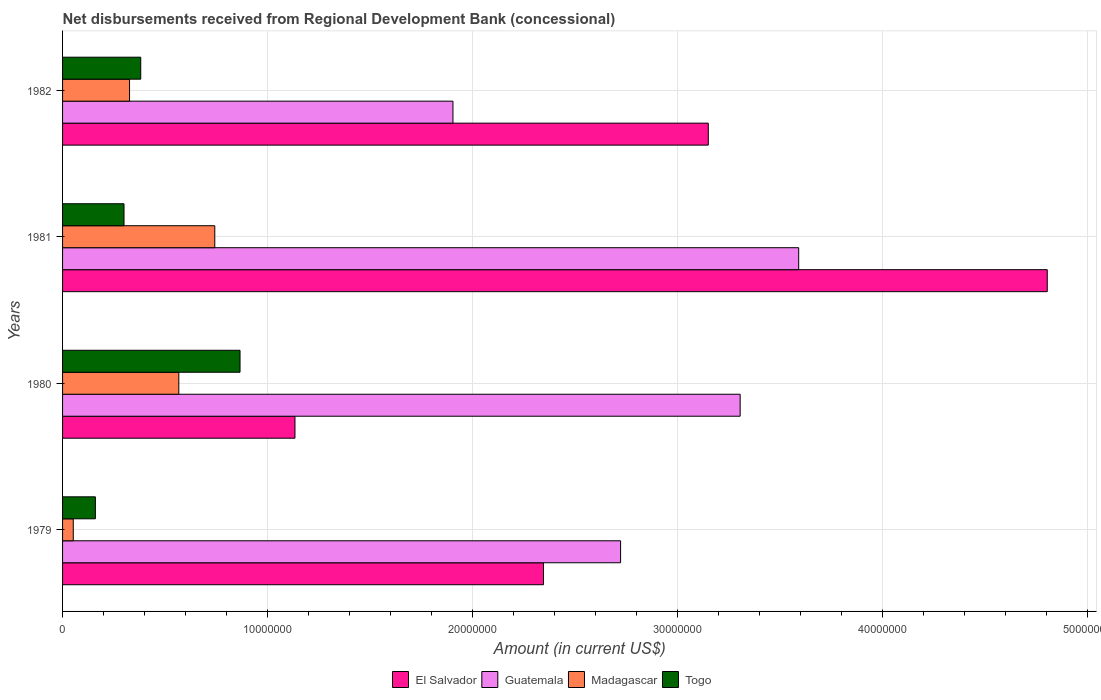How many groups of bars are there?
Make the answer very short. 4. Are the number of bars per tick equal to the number of legend labels?
Provide a short and direct response. Yes. In how many cases, is the number of bars for a given year not equal to the number of legend labels?
Your response must be concise. 0. What is the amount of disbursements received from Regional Development Bank in El Salvador in 1979?
Provide a succinct answer. 2.35e+07. Across all years, what is the maximum amount of disbursements received from Regional Development Bank in Madagascar?
Keep it short and to the point. 7.43e+06. Across all years, what is the minimum amount of disbursements received from Regional Development Bank in El Salvador?
Give a very brief answer. 1.13e+07. In which year was the amount of disbursements received from Regional Development Bank in Madagascar minimum?
Provide a short and direct response. 1979. What is the total amount of disbursements received from Regional Development Bank in Madagascar in the graph?
Offer a very short reply. 1.69e+07. What is the difference between the amount of disbursements received from Regional Development Bank in El Salvador in 1980 and that in 1981?
Offer a very short reply. -3.67e+07. What is the difference between the amount of disbursements received from Regional Development Bank in Guatemala in 1979 and the amount of disbursements received from Regional Development Bank in Madagascar in 1982?
Give a very brief answer. 2.40e+07. What is the average amount of disbursements received from Regional Development Bank in Madagascar per year?
Provide a succinct answer. 4.22e+06. In the year 1979, what is the difference between the amount of disbursements received from Regional Development Bank in Madagascar and amount of disbursements received from Regional Development Bank in Togo?
Ensure brevity in your answer.  -1.08e+06. In how many years, is the amount of disbursements received from Regional Development Bank in Madagascar greater than 34000000 US$?
Your answer should be compact. 0. What is the ratio of the amount of disbursements received from Regional Development Bank in El Salvador in 1979 to that in 1981?
Provide a succinct answer. 0.49. What is the difference between the highest and the second highest amount of disbursements received from Regional Development Bank in Togo?
Keep it short and to the point. 4.84e+06. What is the difference between the highest and the lowest amount of disbursements received from Regional Development Bank in Togo?
Keep it short and to the point. 7.06e+06. Is it the case that in every year, the sum of the amount of disbursements received from Regional Development Bank in Guatemala and amount of disbursements received from Regional Development Bank in Togo is greater than the sum of amount of disbursements received from Regional Development Bank in El Salvador and amount of disbursements received from Regional Development Bank in Madagascar?
Ensure brevity in your answer.  Yes. What does the 4th bar from the top in 1980 represents?
Give a very brief answer. El Salvador. What does the 4th bar from the bottom in 1982 represents?
Your answer should be very brief. Togo. Is it the case that in every year, the sum of the amount of disbursements received from Regional Development Bank in Guatemala and amount of disbursements received from Regional Development Bank in El Salvador is greater than the amount of disbursements received from Regional Development Bank in Togo?
Give a very brief answer. Yes. How many years are there in the graph?
Offer a terse response. 4. What is the difference between two consecutive major ticks on the X-axis?
Provide a succinct answer. 1.00e+07. Are the values on the major ticks of X-axis written in scientific E-notation?
Give a very brief answer. No. Does the graph contain any zero values?
Your response must be concise. No. Does the graph contain grids?
Provide a short and direct response. Yes. How many legend labels are there?
Your answer should be compact. 4. What is the title of the graph?
Your response must be concise. Net disbursements received from Regional Development Bank (concessional). What is the label or title of the X-axis?
Your response must be concise. Amount (in current US$). What is the Amount (in current US$) in El Salvador in 1979?
Offer a terse response. 2.35e+07. What is the Amount (in current US$) of Guatemala in 1979?
Your response must be concise. 2.72e+07. What is the Amount (in current US$) of Madagascar in 1979?
Your answer should be compact. 5.22e+05. What is the Amount (in current US$) in Togo in 1979?
Ensure brevity in your answer.  1.60e+06. What is the Amount (in current US$) of El Salvador in 1980?
Ensure brevity in your answer.  1.13e+07. What is the Amount (in current US$) of Guatemala in 1980?
Offer a terse response. 3.31e+07. What is the Amount (in current US$) of Madagascar in 1980?
Offer a very short reply. 5.67e+06. What is the Amount (in current US$) in Togo in 1980?
Your response must be concise. 8.66e+06. What is the Amount (in current US$) in El Salvador in 1981?
Keep it short and to the point. 4.80e+07. What is the Amount (in current US$) of Guatemala in 1981?
Your answer should be compact. 3.59e+07. What is the Amount (in current US$) of Madagascar in 1981?
Offer a very short reply. 7.43e+06. What is the Amount (in current US$) of Togo in 1981?
Make the answer very short. 3.00e+06. What is the Amount (in current US$) of El Salvador in 1982?
Offer a terse response. 3.15e+07. What is the Amount (in current US$) in Guatemala in 1982?
Provide a succinct answer. 1.90e+07. What is the Amount (in current US$) in Madagascar in 1982?
Your answer should be very brief. 3.27e+06. What is the Amount (in current US$) of Togo in 1982?
Offer a very short reply. 3.81e+06. Across all years, what is the maximum Amount (in current US$) in El Salvador?
Provide a succinct answer. 4.80e+07. Across all years, what is the maximum Amount (in current US$) of Guatemala?
Ensure brevity in your answer.  3.59e+07. Across all years, what is the maximum Amount (in current US$) of Madagascar?
Give a very brief answer. 7.43e+06. Across all years, what is the maximum Amount (in current US$) in Togo?
Keep it short and to the point. 8.66e+06. Across all years, what is the minimum Amount (in current US$) of El Salvador?
Provide a succinct answer. 1.13e+07. Across all years, what is the minimum Amount (in current US$) in Guatemala?
Provide a succinct answer. 1.90e+07. Across all years, what is the minimum Amount (in current US$) in Madagascar?
Your response must be concise. 5.22e+05. Across all years, what is the minimum Amount (in current US$) of Togo?
Give a very brief answer. 1.60e+06. What is the total Amount (in current US$) of El Salvador in the graph?
Provide a short and direct response. 1.14e+08. What is the total Amount (in current US$) of Guatemala in the graph?
Your response must be concise. 1.15e+08. What is the total Amount (in current US$) in Madagascar in the graph?
Offer a very short reply. 1.69e+07. What is the total Amount (in current US$) in Togo in the graph?
Your response must be concise. 1.71e+07. What is the difference between the Amount (in current US$) of El Salvador in 1979 and that in 1980?
Give a very brief answer. 1.21e+07. What is the difference between the Amount (in current US$) in Guatemala in 1979 and that in 1980?
Keep it short and to the point. -5.83e+06. What is the difference between the Amount (in current US$) of Madagascar in 1979 and that in 1980?
Offer a terse response. -5.15e+06. What is the difference between the Amount (in current US$) in Togo in 1979 and that in 1980?
Ensure brevity in your answer.  -7.06e+06. What is the difference between the Amount (in current US$) in El Salvador in 1979 and that in 1981?
Offer a terse response. -2.46e+07. What is the difference between the Amount (in current US$) of Guatemala in 1979 and that in 1981?
Ensure brevity in your answer.  -8.69e+06. What is the difference between the Amount (in current US$) in Madagascar in 1979 and that in 1981?
Your answer should be compact. -6.90e+06. What is the difference between the Amount (in current US$) of Togo in 1979 and that in 1981?
Provide a short and direct response. -1.40e+06. What is the difference between the Amount (in current US$) of El Salvador in 1979 and that in 1982?
Keep it short and to the point. -8.04e+06. What is the difference between the Amount (in current US$) in Guatemala in 1979 and that in 1982?
Your answer should be compact. 8.18e+06. What is the difference between the Amount (in current US$) of Madagascar in 1979 and that in 1982?
Provide a succinct answer. -2.75e+06. What is the difference between the Amount (in current US$) of Togo in 1979 and that in 1982?
Give a very brief answer. -2.21e+06. What is the difference between the Amount (in current US$) of El Salvador in 1980 and that in 1981?
Make the answer very short. -3.67e+07. What is the difference between the Amount (in current US$) in Guatemala in 1980 and that in 1981?
Your answer should be very brief. -2.86e+06. What is the difference between the Amount (in current US$) in Madagascar in 1980 and that in 1981?
Offer a terse response. -1.76e+06. What is the difference between the Amount (in current US$) of Togo in 1980 and that in 1981?
Your response must be concise. 5.66e+06. What is the difference between the Amount (in current US$) of El Salvador in 1980 and that in 1982?
Give a very brief answer. -2.02e+07. What is the difference between the Amount (in current US$) of Guatemala in 1980 and that in 1982?
Keep it short and to the point. 1.40e+07. What is the difference between the Amount (in current US$) of Madagascar in 1980 and that in 1982?
Keep it short and to the point. 2.40e+06. What is the difference between the Amount (in current US$) in Togo in 1980 and that in 1982?
Provide a succinct answer. 4.84e+06. What is the difference between the Amount (in current US$) of El Salvador in 1981 and that in 1982?
Ensure brevity in your answer.  1.65e+07. What is the difference between the Amount (in current US$) of Guatemala in 1981 and that in 1982?
Your answer should be very brief. 1.69e+07. What is the difference between the Amount (in current US$) in Madagascar in 1981 and that in 1982?
Make the answer very short. 4.16e+06. What is the difference between the Amount (in current US$) in Togo in 1981 and that in 1982?
Give a very brief answer. -8.16e+05. What is the difference between the Amount (in current US$) of El Salvador in 1979 and the Amount (in current US$) of Guatemala in 1980?
Your response must be concise. -9.60e+06. What is the difference between the Amount (in current US$) in El Salvador in 1979 and the Amount (in current US$) in Madagascar in 1980?
Provide a short and direct response. 1.78e+07. What is the difference between the Amount (in current US$) of El Salvador in 1979 and the Amount (in current US$) of Togo in 1980?
Your answer should be very brief. 1.48e+07. What is the difference between the Amount (in current US$) of Guatemala in 1979 and the Amount (in current US$) of Madagascar in 1980?
Offer a very short reply. 2.16e+07. What is the difference between the Amount (in current US$) of Guatemala in 1979 and the Amount (in current US$) of Togo in 1980?
Keep it short and to the point. 1.86e+07. What is the difference between the Amount (in current US$) in Madagascar in 1979 and the Amount (in current US$) in Togo in 1980?
Your answer should be very brief. -8.14e+06. What is the difference between the Amount (in current US$) in El Salvador in 1979 and the Amount (in current US$) in Guatemala in 1981?
Provide a succinct answer. -1.25e+07. What is the difference between the Amount (in current US$) in El Salvador in 1979 and the Amount (in current US$) in Madagascar in 1981?
Provide a succinct answer. 1.60e+07. What is the difference between the Amount (in current US$) in El Salvador in 1979 and the Amount (in current US$) in Togo in 1981?
Your response must be concise. 2.05e+07. What is the difference between the Amount (in current US$) in Guatemala in 1979 and the Amount (in current US$) in Madagascar in 1981?
Keep it short and to the point. 1.98e+07. What is the difference between the Amount (in current US$) of Guatemala in 1979 and the Amount (in current US$) of Togo in 1981?
Your answer should be very brief. 2.42e+07. What is the difference between the Amount (in current US$) in Madagascar in 1979 and the Amount (in current US$) in Togo in 1981?
Your response must be concise. -2.48e+06. What is the difference between the Amount (in current US$) in El Salvador in 1979 and the Amount (in current US$) in Guatemala in 1982?
Offer a terse response. 4.42e+06. What is the difference between the Amount (in current US$) in El Salvador in 1979 and the Amount (in current US$) in Madagascar in 1982?
Provide a succinct answer. 2.02e+07. What is the difference between the Amount (in current US$) of El Salvador in 1979 and the Amount (in current US$) of Togo in 1982?
Your response must be concise. 1.96e+07. What is the difference between the Amount (in current US$) of Guatemala in 1979 and the Amount (in current US$) of Madagascar in 1982?
Your answer should be compact. 2.40e+07. What is the difference between the Amount (in current US$) of Guatemala in 1979 and the Amount (in current US$) of Togo in 1982?
Offer a terse response. 2.34e+07. What is the difference between the Amount (in current US$) of Madagascar in 1979 and the Amount (in current US$) of Togo in 1982?
Your response must be concise. -3.29e+06. What is the difference between the Amount (in current US$) in El Salvador in 1980 and the Amount (in current US$) in Guatemala in 1981?
Your answer should be very brief. -2.46e+07. What is the difference between the Amount (in current US$) in El Salvador in 1980 and the Amount (in current US$) in Madagascar in 1981?
Keep it short and to the point. 3.91e+06. What is the difference between the Amount (in current US$) of El Salvador in 1980 and the Amount (in current US$) of Togo in 1981?
Keep it short and to the point. 8.34e+06. What is the difference between the Amount (in current US$) of Guatemala in 1980 and the Amount (in current US$) of Madagascar in 1981?
Provide a succinct answer. 2.56e+07. What is the difference between the Amount (in current US$) of Guatemala in 1980 and the Amount (in current US$) of Togo in 1981?
Offer a terse response. 3.01e+07. What is the difference between the Amount (in current US$) of Madagascar in 1980 and the Amount (in current US$) of Togo in 1981?
Your answer should be compact. 2.67e+06. What is the difference between the Amount (in current US$) of El Salvador in 1980 and the Amount (in current US$) of Guatemala in 1982?
Make the answer very short. -7.71e+06. What is the difference between the Amount (in current US$) in El Salvador in 1980 and the Amount (in current US$) in Madagascar in 1982?
Provide a short and direct response. 8.07e+06. What is the difference between the Amount (in current US$) in El Salvador in 1980 and the Amount (in current US$) in Togo in 1982?
Ensure brevity in your answer.  7.52e+06. What is the difference between the Amount (in current US$) of Guatemala in 1980 and the Amount (in current US$) of Madagascar in 1982?
Ensure brevity in your answer.  2.98e+07. What is the difference between the Amount (in current US$) of Guatemala in 1980 and the Amount (in current US$) of Togo in 1982?
Provide a succinct answer. 2.92e+07. What is the difference between the Amount (in current US$) of Madagascar in 1980 and the Amount (in current US$) of Togo in 1982?
Keep it short and to the point. 1.86e+06. What is the difference between the Amount (in current US$) in El Salvador in 1981 and the Amount (in current US$) in Guatemala in 1982?
Offer a terse response. 2.90e+07. What is the difference between the Amount (in current US$) of El Salvador in 1981 and the Amount (in current US$) of Madagascar in 1982?
Your answer should be compact. 4.48e+07. What is the difference between the Amount (in current US$) in El Salvador in 1981 and the Amount (in current US$) in Togo in 1982?
Your answer should be compact. 4.42e+07. What is the difference between the Amount (in current US$) of Guatemala in 1981 and the Amount (in current US$) of Madagascar in 1982?
Your answer should be compact. 3.26e+07. What is the difference between the Amount (in current US$) of Guatemala in 1981 and the Amount (in current US$) of Togo in 1982?
Make the answer very short. 3.21e+07. What is the difference between the Amount (in current US$) in Madagascar in 1981 and the Amount (in current US$) in Togo in 1982?
Make the answer very short. 3.61e+06. What is the average Amount (in current US$) of El Salvador per year?
Keep it short and to the point. 2.86e+07. What is the average Amount (in current US$) in Guatemala per year?
Offer a very short reply. 2.88e+07. What is the average Amount (in current US$) of Madagascar per year?
Ensure brevity in your answer.  4.22e+06. What is the average Amount (in current US$) in Togo per year?
Provide a succinct answer. 4.27e+06. In the year 1979, what is the difference between the Amount (in current US$) of El Salvador and Amount (in current US$) of Guatemala?
Keep it short and to the point. -3.76e+06. In the year 1979, what is the difference between the Amount (in current US$) of El Salvador and Amount (in current US$) of Madagascar?
Offer a terse response. 2.29e+07. In the year 1979, what is the difference between the Amount (in current US$) of El Salvador and Amount (in current US$) of Togo?
Your response must be concise. 2.19e+07. In the year 1979, what is the difference between the Amount (in current US$) in Guatemala and Amount (in current US$) in Madagascar?
Your answer should be very brief. 2.67e+07. In the year 1979, what is the difference between the Amount (in current US$) of Guatemala and Amount (in current US$) of Togo?
Your answer should be compact. 2.56e+07. In the year 1979, what is the difference between the Amount (in current US$) in Madagascar and Amount (in current US$) in Togo?
Your response must be concise. -1.08e+06. In the year 1980, what is the difference between the Amount (in current US$) in El Salvador and Amount (in current US$) in Guatemala?
Your answer should be compact. -2.17e+07. In the year 1980, what is the difference between the Amount (in current US$) in El Salvador and Amount (in current US$) in Madagascar?
Offer a very short reply. 5.67e+06. In the year 1980, what is the difference between the Amount (in current US$) of El Salvador and Amount (in current US$) of Togo?
Offer a terse response. 2.68e+06. In the year 1980, what is the difference between the Amount (in current US$) of Guatemala and Amount (in current US$) of Madagascar?
Provide a short and direct response. 2.74e+07. In the year 1980, what is the difference between the Amount (in current US$) of Guatemala and Amount (in current US$) of Togo?
Provide a succinct answer. 2.44e+07. In the year 1980, what is the difference between the Amount (in current US$) in Madagascar and Amount (in current US$) in Togo?
Keep it short and to the point. -2.99e+06. In the year 1981, what is the difference between the Amount (in current US$) of El Salvador and Amount (in current US$) of Guatemala?
Your answer should be compact. 1.21e+07. In the year 1981, what is the difference between the Amount (in current US$) in El Salvador and Amount (in current US$) in Madagascar?
Ensure brevity in your answer.  4.06e+07. In the year 1981, what is the difference between the Amount (in current US$) of El Salvador and Amount (in current US$) of Togo?
Make the answer very short. 4.50e+07. In the year 1981, what is the difference between the Amount (in current US$) in Guatemala and Amount (in current US$) in Madagascar?
Your response must be concise. 2.85e+07. In the year 1981, what is the difference between the Amount (in current US$) in Guatemala and Amount (in current US$) in Togo?
Offer a terse response. 3.29e+07. In the year 1981, what is the difference between the Amount (in current US$) in Madagascar and Amount (in current US$) in Togo?
Make the answer very short. 4.43e+06. In the year 1982, what is the difference between the Amount (in current US$) of El Salvador and Amount (in current US$) of Guatemala?
Keep it short and to the point. 1.25e+07. In the year 1982, what is the difference between the Amount (in current US$) in El Salvador and Amount (in current US$) in Madagascar?
Give a very brief answer. 2.82e+07. In the year 1982, what is the difference between the Amount (in current US$) of El Salvador and Amount (in current US$) of Togo?
Keep it short and to the point. 2.77e+07. In the year 1982, what is the difference between the Amount (in current US$) of Guatemala and Amount (in current US$) of Madagascar?
Give a very brief answer. 1.58e+07. In the year 1982, what is the difference between the Amount (in current US$) of Guatemala and Amount (in current US$) of Togo?
Your answer should be compact. 1.52e+07. In the year 1982, what is the difference between the Amount (in current US$) in Madagascar and Amount (in current US$) in Togo?
Keep it short and to the point. -5.46e+05. What is the ratio of the Amount (in current US$) of El Salvador in 1979 to that in 1980?
Offer a terse response. 2.07. What is the ratio of the Amount (in current US$) of Guatemala in 1979 to that in 1980?
Offer a very short reply. 0.82. What is the ratio of the Amount (in current US$) in Madagascar in 1979 to that in 1980?
Make the answer very short. 0.09. What is the ratio of the Amount (in current US$) in Togo in 1979 to that in 1980?
Offer a terse response. 0.18. What is the ratio of the Amount (in current US$) in El Salvador in 1979 to that in 1981?
Offer a terse response. 0.49. What is the ratio of the Amount (in current US$) in Guatemala in 1979 to that in 1981?
Make the answer very short. 0.76. What is the ratio of the Amount (in current US$) of Madagascar in 1979 to that in 1981?
Offer a terse response. 0.07. What is the ratio of the Amount (in current US$) of Togo in 1979 to that in 1981?
Make the answer very short. 0.53. What is the ratio of the Amount (in current US$) in El Salvador in 1979 to that in 1982?
Offer a terse response. 0.74. What is the ratio of the Amount (in current US$) of Guatemala in 1979 to that in 1982?
Your answer should be very brief. 1.43. What is the ratio of the Amount (in current US$) in Madagascar in 1979 to that in 1982?
Ensure brevity in your answer.  0.16. What is the ratio of the Amount (in current US$) of Togo in 1979 to that in 1982?
Provide a succinct answer. 0.42. What is the ratio of the Amount (in current US$) in El Salvador in 1980 to that in 1981?
Offer a terse response. 0.24. What is the ratio of the Amount (in current US$) of Guatemala in 1980 to that in 1981?
Offer a terse response. 0.92. What is the ratio of the Amount (in current US$) of Madagascar in 1980 to that in 1981?
Provide a succinct answer. 0.76. What is the ratio of the Amount (in current US$) of Togo in 1980 to that in 1981?
Give a very brief answer. 2.89. What is the ratio of the Amount (in current US$) in El Salvador in 1980 to that in 1982?
Provide a short and direct response. 0.36. What is the ratio of the Amount (in current US$) of Guatemala in 1980 to that in 1982?
Your response must be concise. 1.74. What is the ratio of the Amount (in current US$) in Madagascar in 1980 to that in 1982?
Offer a very short reply. 1.74. What is the ratio of the Amount (in current US$) of Togo in 1980 to that in 1982?
Give a very brief answer. 2.27. What is the ratio of the Amount (in current US$) of El Salvador in 1981 to that in 1982?
Offer a terse response. 1.52. What is the ratio of the Amount (in current US$) in Guatemala in 1981 to that in 1982?
Your answer should be compact. 1.89. What is the ratio of the Amount (in current US$) in Madagascar in 1981 to that in 1982?
Offer a very short reply. 2.27. What is the ratio of the Amount (in current US$) in Togo in 1981 to that in 1982?
Provide a succinct answer. 0.79. What is the difference between the highest and the second highest Amount (in current US$) of El Salvador?
Offer a terse response. 1.65e+07. What is the difference between the highest and the second highest Amount (in current US$) in Guatemala?
Provide a succinct answer. 2.86e+06. What is the difference between the highest and the second highest Amount (in current US$) in Madagascar?
Make the answer very short. 1.76e+06. What is the difference between the highest and the second highest Amount (in current US$) of Togo?
Keep it short and to the point. 4.84e+06. What is the difference between the highest and the lowest Amount (in current US$) of El Salvador?
Provide a short and direct response. 3.67e+07. What is the difference between the highest and the lowest Amount (in current US$) in Guatemala?
Keep it short and to the point. 1.69e+07. What is the difference between the highest and the lowest Amount (in current US$) of Madagascar?
Provide a succinct answer. 6.90e+06. What is the difference between the highest and the lowest Amount (in current US$) of Togo?
Offer a very short reply. 7.06e+06. 